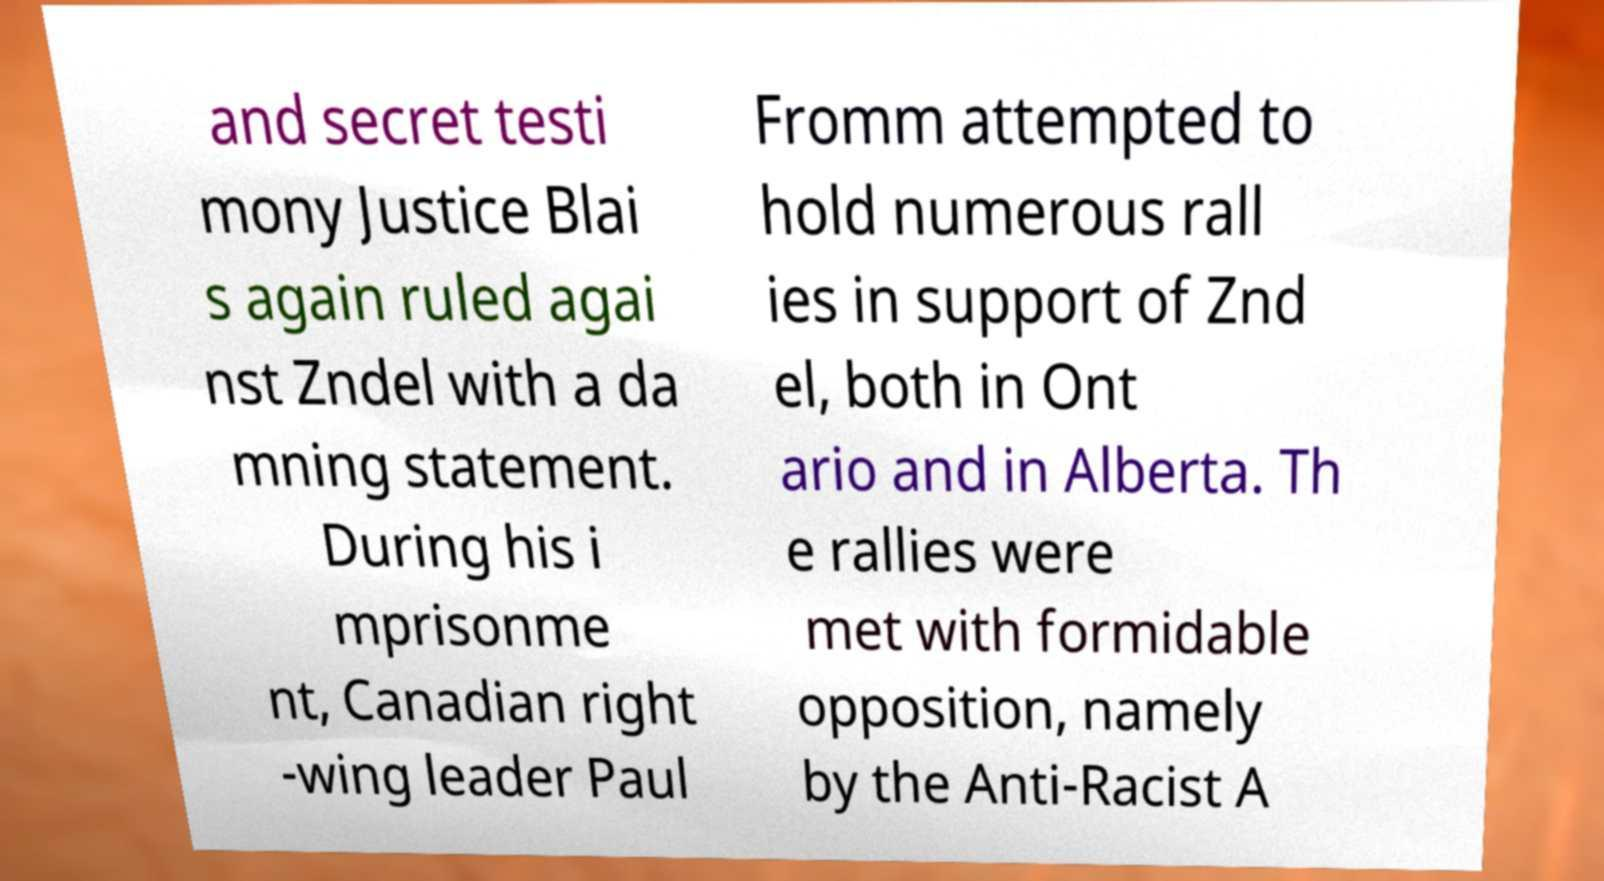Could you assist in decoding the text presented in this image and type it out clearly? and secret testi mony Justice Blai s again ruled agai nst Zndel with a da mning statement. During his i mprisonme nt, Canadian right -wing leader Paul Fromm attempted to hold numerous rall ies in support of Znd el, both in Ont ario and in Alberta. Th e rallies were met with formidable opposition, namely by the Anti-Racist A 